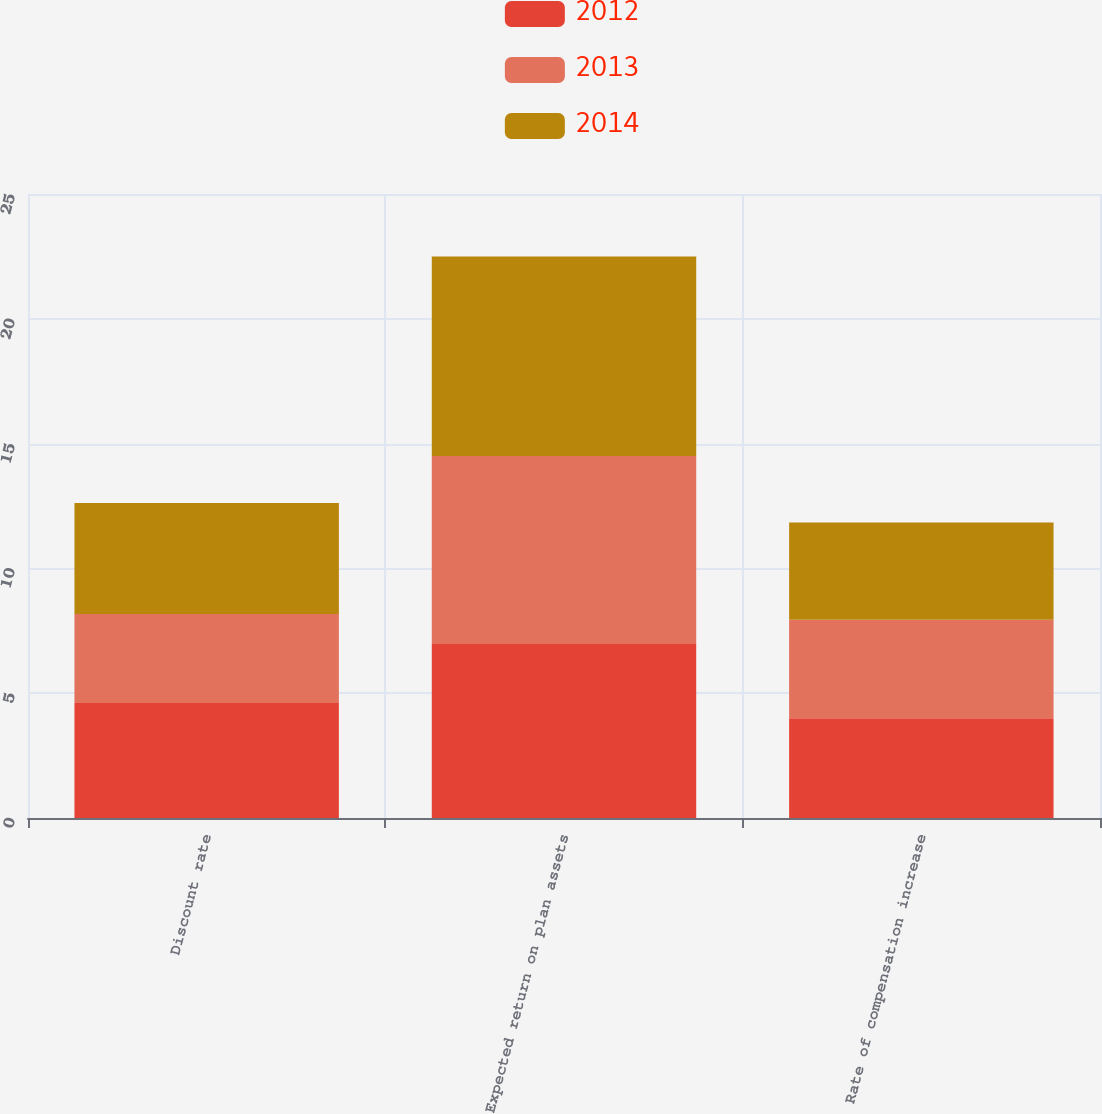<chart> <loc_0><loc_0><loc_500><loc_500><stacked_bar_chart><ecel><fcel>Discount rate<fcel>Expected return on plan assets<fcel>Rate of compensation increase<nl><fcel>2012<fcel>4.61<fcel>7<fcel>4<nl><fcel>2013<fcel>3.56<fcel>7.5<fcel>3.94<nl><fcel>2014<fcel>4.45<fcel>8<fcel>3.9<nl></chart> 